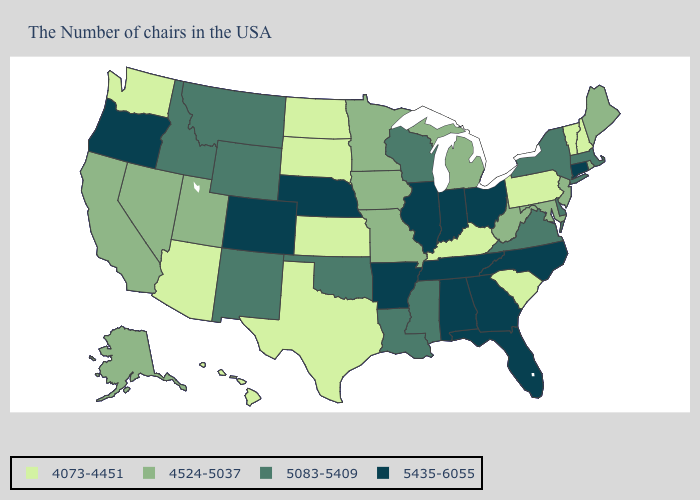Does California have the highest value in the West?
Be succinct. No. What is the value of Iowa?
Be succinct. 4524-5037. What is the value of Wisconsin?
Short answer required. 5083-5409. Name the states that have a value in the range 4524-5037?
Quick response, please. Maine, Rhode Island, New Jersey, Maryland, West Virginia, Michigan, Missouri, Minnesota, Iowa, Utah, Nevada, California, Alaska. Among the states that border South Carolina , which have the lowest value?
Answer briefly. North Carolina, Georgia. What is the highest value in the Northeast ?
Keep it brief. 5435-6055. Name the states that have a value in the range 5083-5409?
Be succinct. Massachusetts, New York, Delaware, Virginia, Wisconsin, Mississippi, Louisiana, Oklahoma, Wyoming, New Mexico, Montana, Idaho. What is the value of Tennessee?
Quick response, please. 5435-6055. Does South Dakota have the lowest value in the USA?
Short answer required. Yes. Among the states that border Florida , which have the highest value?
Short answer required. Georgia, Alabama. Name the states that have a value in the range 4073-4451?
Concise answer only. New Hampshire, Vermont, Pennsylvania, South Carolina, Kentucky, Kansas, Texas, South Dakota, North Dakota, Arizona, Washington, Hawaii. Does Virginia have the same value as Nebraska?
Short answer required. No. Among the states that border Arizona , does Nevada have the lowest value?
Answer briefly. Yes. Does West Virginia have the highest value in the USA?
Quick response, please. No. Which states have the highest value in the USA?
Short answer required. Connecticut, North Carolina, Ohio, Florida, Georgia, Indiana, Alabama, Tennessee, Illinois, Arkansas, Nebraska, Colorado, Oregon. 